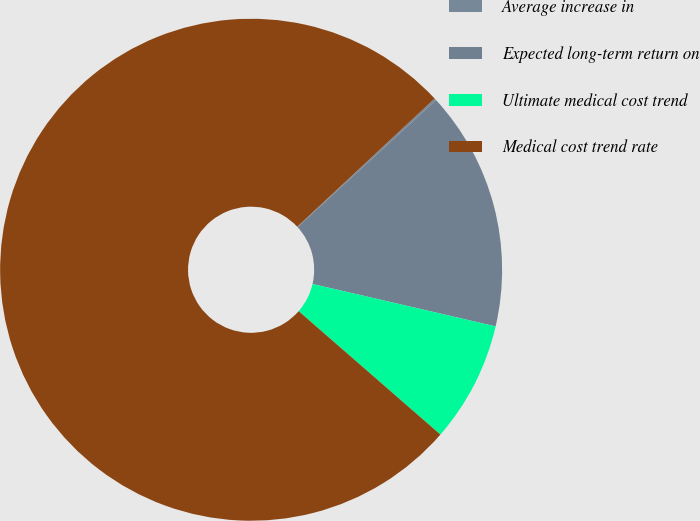<chart> <loc_0><loc_0><loc_500><loc_500><pie_chart><fcel>Average increase in<fcel>Expected long-term return on<fcel>Ultimate medical cost trend<fcel>Medical cost trend rate<nl><fcel>0.13%<fcel>15.44%<fcel>7.78%<fcel>76.65%<nl></chart> 